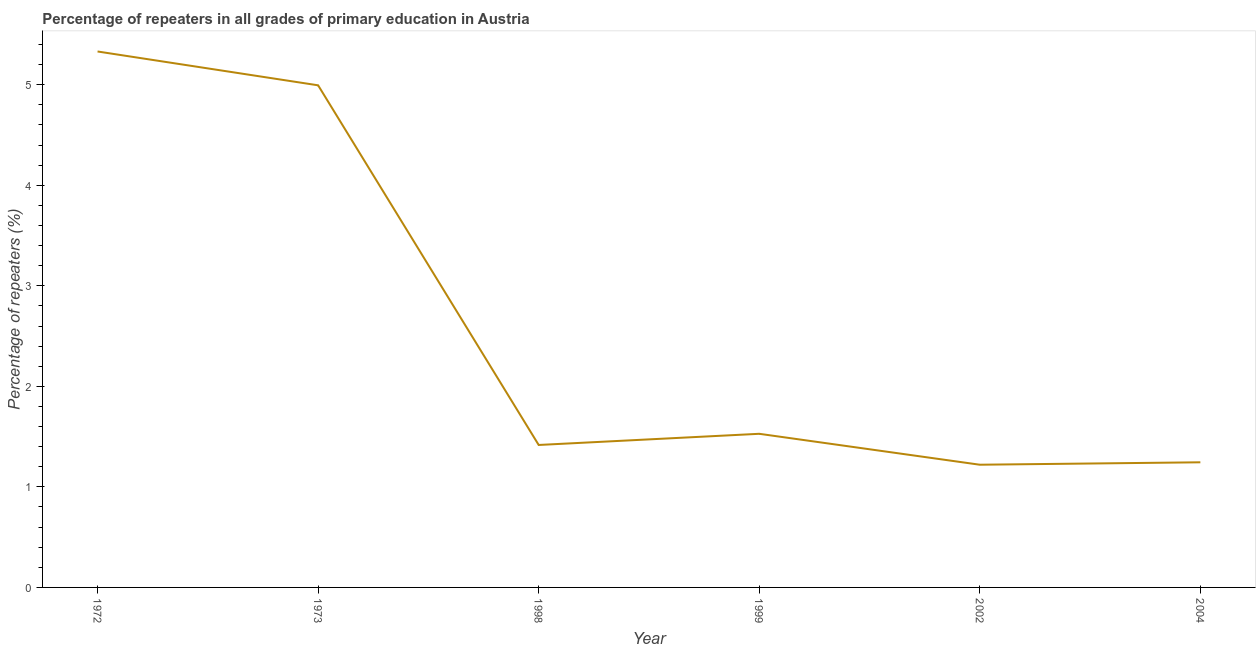What is the percentage of repeaters in primary education in 1999?
Provide a succinct answer. 1.53. Across all years, what is the maximum percentage of repeaters in primary education?
Keep it short and to the point. 5.33. Across all years, what is the minimum percentage of repeaters in primary education?
Ensure brevity in your answer.  1.22. In which year was the percentage of repeaters in primary education maximum?
Your answer should be compact. 1972. In which year was the percentage of repeaters in primary education minimum?
Provide a short and direct response. 2002. What is the sum of the percentage of repeaters in primary education?
Your answer should be very brief. 15.74. What is the difference between the percentage of repeaters in primary education in 1972 and 2002?
Your answer should be very brief. 4.11. What is the average percentage of repeaters in primary education per year?
Provide a short and direct response. 2.62. What is the median percentage of repeaters in primary education?
Keep it short and to the point. 1.47. Do a majority of the years between 1998 and 1973 (inclusive) have percentage of repeaters in primary education greater than 4 %?
Your response must be concise. No. What is the ratio of the percentage of repeaters in primary education in 2002 to that in 2004?
Your answer should be very brief. 0.98. Is the percentage of repeaters in primary education in 1973 less than that in 1998?
Offer a terse response. No. Is the difference between the percentage of repeaters in primary education in 1972 and 1973 greater than the difference between any two years?
Offer a very short reply. No. What is the difference between the highest and the second highest percentage of repeaters in primary education?
Your response must be concise. 0.34. Is the sum of the percentage of repeaters in primary education in 1972 and 1999 greater than the maximum percentage of repeaters in primary education across all years?
Provide a short and direct response. Yes. What is the difference between the highest and the lowest percentage of repeaters in primary education?
Provide a short and direct response. 4.11. Does the percentage of repeaters in primary education monotonically increase over the years?
Your answer should be compact. No. What is the difference between two consecutive major ticks on the Y-axis?
Keep it short and to the point. 1. Are the values on the major ticks of Y-axis written in scientific E-notation?
Provide a short and direct response. No. Does the graph contain any zero values?
Offer a very short reply. No. What is the title of the graph?
Give a very brief answer. Percentage of repeaters in all grades of primary education in Austria. What is the label or title of the X-axis?
Offer a very short reply. Year. What is the label or title of the Y-axis?
Keep it short and to the point. Percentage of repeaters (%). What is the Percentage of repeaters (%) of 1972?
Offer a very short reply. 5.33. What is the Percentage of repeaters (%) in 1973?
Offer a very short reply. 4.99. What is the Percentage of repeaters (%) of 1998?
Your answer should be very brief. 1.42. What is the Percentage of repeaters (%) of 1999?
Keep it short and to the point. 1.53. What is the Percentage of repeaters (%) of 2002?
Your answer should be compact. 1.22. What is the Percentage of repeaters (%) of 2004?
Provide a succinct answer. 1.24. What is the difference between the Percentage of repeaters (%) in 1972 and 1973?
Make the answer very short. 0.34. What is the difference between the Percentage of repeaters (%) in 1972 and 1998?
Your response must be concise. 3.91. What is the difference between the Percentage of repeaters (%) in 1972 and 1999?
Offer a terse response. 3.8. What is the difference between the Percentage of repeaters (%) in 1972 and 2002?
Provide a succinct answer. 4.11. What is the difference between the Percentage of repeaters (%) in 1972 and 2004?
Your answer should be very brief. 4.09. What is the difference between the Percentage of repeaters (%) in 1973 and 1998?
Your answer should be very brief. 3.58. What is the difference between the Percentage of repeaters (%) in 1973 and 1999?
Keep it short and to the point. 3.47. What is the difference between the Percentage of repeaters (%) in 1973 and 2002?
Make the answer very short. 3.77. What is the difference between the Percentage of repeaters (%) in 1973 and 2004?
Your response must be concise. 3.75. What is the difference between the Percentage of repeaters (%) in 1998 and 1999?
Offer a terse response. -0.11. What is the difference between the Percentage of repeaters (%) in 1998 and 2002?
Keep it short and to the point. 0.2. What is the difference between the Percentage of repeaters (%) in 1998 and 2004?
Offer a terse response. 0.17. What is the difference between the Percentage of repeaters (%) in 1999 and 2002?
Make the answer very short. 0.31. What is the difference between the Percentage of repeaters (%) in 1999 and 2004?
Provide a short and direct response. 0.28. What is the difference between the Percentage of repeaters (%) in 2002 and 2004?
Offer a terse response. -0.02. What is the ratio of the Percentage of repeaters (%) in 1972 to that in 1973?
Your answer should be very brief. 1.07. What is the ratio of the Percentage of repeaters (%) in 1972 to that in 1998?
Your answer should be very brief. 3.76. What is the ratio of the Percentage of repeaters (%) in 1972 to that in 1999?
Your answer should be very brief. 3.49. What is the ratio of the Percentage of repeaters (%) in 1972 to that in 2002?
Make the answer very short. 4.37. What is the ratio of the Percentage of repeaters (%) in 1972 to that in 2004?
Ensure brevity in your answer.  4.28. What is the ratio of the Percentage of repeaters (%) in 1973 to that in 1998?
Offer a terse response. 3.52. What is the ratio of the Percentage of repeaters (%) in 1973 to that in 1999?
Make the answer very short. 3.27. What is the ratio of the Percentage of repeaters (%) in 1973 to that in 2002?
Your answer should be very brief. 4.09. What is the ratio of the Percentage of repeaters (%) in 1973 to that in 2004?
Your response must be concise. 4.01. What is the ratio of the Percentage of repeaters (%) in 1998 to that in 1999?
Give a very brief answer. 0.93. What is the ratio of the Percentage of repeaters (%) in 1998 to that in 2002?
Offer a very short reply. 1.16. What is the ratio of the Percentage of repeaters (%) in 1998 to that in 2004?
Provide a succinct answer. 1.14. What is the ratio of the Percentage of repeaters (%) in 1999 to that in 2002?
Your answer should be very brief. 1.25. What is the ratio of the Percentage of repeaters (%) in 1999 to that in 2004?
Provide a short and direct response. 1.23. 